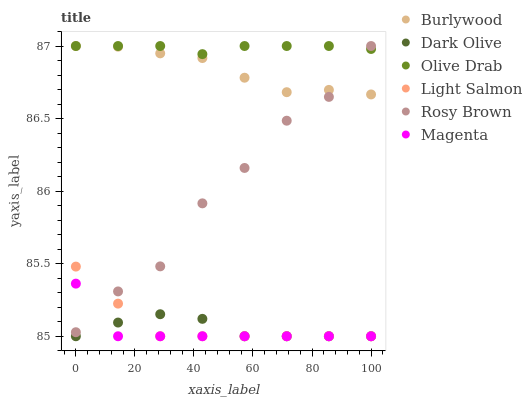Does Magenta have the minimum area under the curve?
Answer yes or no. Yes. Does Olive Drab have the maximum area under the curve?
Answer yes or no. Yes. Does Rosy Brown have the minimum area under the curve?
Answer yes or no. No. Does Rosy Brown have the maximum area under the curve?
Answer yes or no. No. Is Olive Drab the smoothest?
Answer yes or no. Yes. Is Rosy Brown the roughest?
Answer yes or no. Yes. Is Burlywood the smoothest?
Answer yes or no. No. Is Burlywood the roughest?
Answer yes or no. No. Does Light Salmon have the lowest value?
Answer yes or no. Yes. Does Rosy Brown have the lowest value?
Answer yes or no. No. Does Olive Drab have the highest value?
Answer yes or no. Yes. Does Dark Olive have the highest value?
Answer yes or no. No. Is Light Salmon less than Olive Drab?
Answer yes or no. Yes. Is Olive Drab greater than Dark Olive?
Answer yes or no. Yes. Does Magenta intersect Light Salmon?
Answer yes or no. Yes. Is Magenta less than Light Salmon?
Answer yes or no. No. Is Magenta greater than Light Salmon?
Answer yes or no. No. Does Light Salmon intersect Olive Drab?
Answer yes or no. No. 